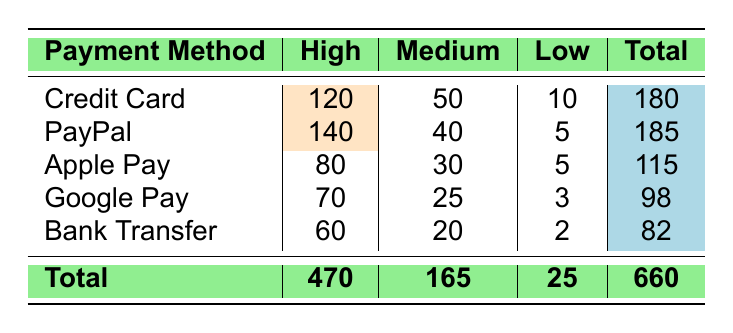What is the customer satisfaction rating count for PayPal? For PayPal, the table shows three ratings: High (140), Medium (40), and Low (5). Therefore, to answer the question, we simply refer to the table and find these counts for PayPal.
Answer: 140, 40, 5 How many customers rated Apple Pay as Medium? The table directly lists the count for Apple Pay under the Medium rating, which is stated as 30. We don't need to perform any calculations here.
Answer: 30 Which payment method received the highest customer satisfaction rating of High? By comparing the counts for each payment method under the High rating, we see that PayPal has the highest count of 140. This requires a comparison among all payment methods.
Answer: PayPal What is the total count of customers who rated their satisfaction as Low across all payment methods? To find this, we need to sum the Low ratings: 10 (Credit Card) + 5 (PayPal) + 5 (Apple Pay) + 3 (Google Pay) + 2 (Bank Transfer) = 25. This involves both retrieval from the table and summation.
Answer: 25 Is it true that more customers rated their satisfaction as High for Credit Card than for Google Pay? For Credit Card, the High rating count is 120, while for Google Pay it is 70. Since 120 is greater than 70, the statement is true. We compare the High ratings from both payment methods to verify this.
Answer: Yes What is the average count of customer satisfaction ratings for the payment method with the lowest overall total? The overall totals for each payment method are as follows: Credit Card (180), PayPal (185), Apple Pay (115), Google Pay (98), and Bank Transfer (82). Bank Transfer has the lowest total of 82. To find the average, we consider all ratings (High, Medium, Low), which are 60 (High) + 20 (Medium) + 2 (Low) = 82. The average is 82/3 ≈ 27.33. This involves multiple steps: finding the lowest total, summing its ratings, and getting the average.
Answer: 27.33 Which payment method has the least count of customers rating their satisfaction as Medium? By examining the counts for Medium ratings: Credit Card (50), PayPal (40), Apple Pay (30), Google Pay (25), and Bank Transfer (20), we can see that Bank Transfer has the lowest count at 20. This requires a comparison of all Medium ratings from the table.
Answer: Bank Transfer What is the difference in the High rating counts between Credit Card and Apple Pay? Credit Card has 120 counts for High ratings, while Apple Pay has 80. The difference is calculated by subtracting: 120 - 80 = 40. This is a simple subtraction operation based on data from the table.
Answer: 40 How many total customers participated in the survey? The total customers can be obtained by summing all the counts from the table: 180 (Credit Card) + 185 (PayPal) + 115 (Apple Pay) + 98 (Google Pay) + 82 (Bank Transfer) = 660. This requires summing the totals of each payment method.
Answer: 660 